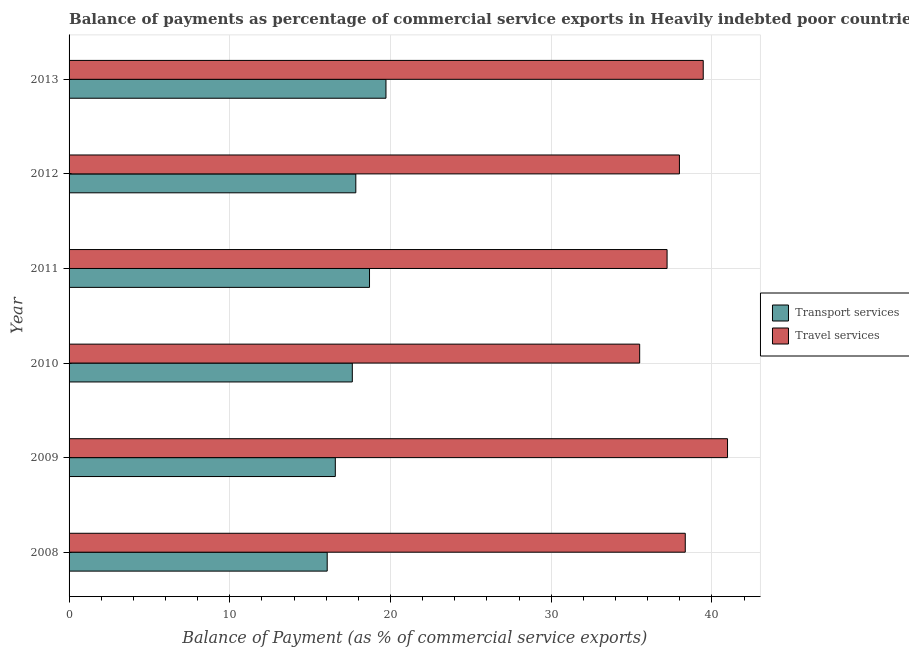How many groups of bars are there?
Ensure brevity in your answer.  6. Are the number of bars per tick equal to the number of legend labels?
Provide a short and direct response. Yes. How many bars are there on the 4th tick from the bottom?
Provide a succinct answer. 2. What is the label of the 5th group of bars from the top?
Provide a short and direct response. 2009. In how many cases, is the number of bars for a given year not equal to the number of legend labels?
Your answer should be very brief. 0. What is the balance of payments of transport services in 2013?
Provide a succinct answer. 19.72. Across all years, what is the maximum balance of payments of travel services?
Provide a succinct answer. 40.97. Across all years, what is the minimum balance of payments of transport services?
Your response must be concise. 16.06. In which year was the balance of payments of transport services maximum?
Provide a short and direct response. 2013. In which year was the balance of payments of transport services minimum?
Offer a terse response. 2008. What is the total balance of payments of transport services in the graph?
Make the answer very short. 106.5. What is the difference between the balance of payments of travel services in 2008 and that in 2013?
Give a very brief answer. -1.12. What is the difference between the balance of payments of travel services in 2013 and the balance of payments of transport services in 2010?
Provide a succinct answer. 21.83. What is the average balance of payments of travel services per year?
Ensure brevity in your answer.  38.24. In the year 2010, what is the difference between the balance of payments of transport services and balance of payments of travel services?
Your answer should be compact. -17.88. In how many years, is the balance of payments of travel services greater than 8 %?
Your answer should be compact. 6. What is the ratio of the balance of payments of transport services in 2009 to that in 2013?
Your response must be concise. 0.84. Is the balance of payments of transport services in 2009 less than that in 2010?
Give a very brief answer. Yes. Is the difference between the balance of payments of transport services in 2008 and 2009 greater than the difference between the balance of payments of travel services in 2008 and 2009?
Your answer should be very brief. Yes. What is the difference between the highest and the second highest balance of payments of transport services?
Provide a succinct answer. 1.02. What is the difference between the highest and the lowest balance of payments of travel services?
Make the answer very short. 5.47. What does the 1st bar from the top in 2010 represents?
Keep it short and to the point. Travel services. What does the 2nd bar from the bottom in 2009 represents?
Offer a terse response. Travel services. How many bars are there?
Your answer should be compact. 12. Are all the bars in the graph horizontal?
Provide a succinct answer. Yes. Are the values on the major ticks of X-axis written in scientific E-notation?
Offer a very short reply. No. What is the title of the graph?
Your answer should be very brief. Balance of payments as percentage of commercial service exports in Heavily indebted poor countries. Does "current US$" appear as one of the legend labels in the graph?
Your answer should be compact. No. What is the label or title of the X-axis?
Ensure brevity in your answer.  Balance of Payment (as % of commercial service exports). What is the Balance of Payment (as % of commercial service exports) in Transport services in 2008?
Offer a terse response. 16.06. What is the Balance of Payment (as % of commercial service exports) in Travel services in 2008?
Offer a terse response. 38.34. What is the Balance of Payment (as % of commercial service exports) of Transport services in 2009?
Keep it short and to the point. 16.57. What is the Balance of Payment (as % of commercial service exports) of Travel services in 2009?
Keep it short and to the point. 40.97. What is the Balance of Payment (as % of commercial service exports) in Transport services in 2010?
Your answer should be very brief. 17.62. What is the Balance of Payment (as % of commercial service exports) of Travel services in 2010?
Give a very brief answer. 35.5. What is the Balance of Payment (as % of commercial service exports) of Transport services in 2011?
Ensure brevity in your answer.  18.69. What is the Balance of Payment (as % of commercial service exports) in Travel services in 2011?
Offer a terse response. 37.21. What is the Balance of Payment (as % of commercial service exports) in Transport services in 2012?
Your answer should be compact. 17.84. What is the Balance of Payment (as % of commercial service exports) in Travel services in 2012?
Your answer should be very brief. 37.97. What is the Balance of Payment (as % of commercial service exports) in Transport services in 2013?
Provide a short and direct response. 19.72. What is the Balance of Payment (as % of commercial service exports) of Travel services in 2013?
Give a very brief answer. 39.46. Across all years, what is the maximum Balance of Payment (as % of commercial service exports) in Transport services?
Your answer should be compact. 19.72. Across all years, what is the maximum Balance of Payment (as % of commercial service exports) in Travel services?
Offer a very short reply. 40.97. Across all years, what is the minimum Balance of Payment (as % of commercial service exports) of Transport services?
Your answer should be very brief. 16.06. Across all years, what is the minimum Balance of Payment (as % of commercial service exports) in Travel services?
Your answer should be compact. 35.5. What is the total Balance of Payment (as % of commercial service exports) in Transport services in the graph?
Make the answer very short. 106.5. What is the total Balance of Payment (as % of commercial service exports) in Travel services in the graph?
Provide a succinct answer. 229.45. What is the difference between the Balance of Payment (as % of commercial service exports) in Transport services in 2008 and that in 2009?
Provide a short and direct response. -0.51. What is the difference between the Balance of Payment (as % of commercial service exports) in Travel services in 2008 and that in 2009?
Offer a very short reply. -2.63. What is the difference between the Balance of Payment (as % of commercial service exports) of Transport services in 2008 and that in 2010?
Your response must be concise. -1.56. What is the difference between the Balance of Payment (as % of commercial service exports) of Travel services in 2008 and that in 2010?
Provide a succinct answer. 2.84. What is the difference between the Balance of Payment (as % of commercial service exports) in Transport services in 2008 and that in 2011?
Your answer should be very brief. -2.63. What is the difference between the Balance of Payment (as % of commercial service exports) of Travel services in 2008 and that in 2011?
Offer a terse response. 1.13. What is the difference between the Balance of Payment (as % of commercial service exports) in Transport services in 2008 and that in 2012?
Make the answer very short. -1.78. What is the difference between the Balance of Payment (as % of commercial service exports) in Travel services in 2008 and that in 2012?
Your response must be concise. 0.36. What is the difference between the Balance of Payment (as % of commercial service exports) of Transport services in 2008 and that in 2013?
Offer a very short reply. -3.66. What is the difference between the Balance of Payment (as % of commercial service exports) in Travel services in 2008 and that in 2013?
Provide a succinct answer. -1.12. What is the difference between the Balance of Payment (as % of commercial service exports) of Transport services in 2009 and that in 2010?
Offer a terse response. -1.06. What is the difference between the Balance of Payment (as % of commercial service exports) of Travel services in 2009 and that in 2010?
Offer a very short reply. 5.47. What is the difference between the Balance of Payment (as % of commercial service exports) of Transport services in 2009 and that in 2011?
Offer a terse response. -2.13. What is the difference between the Balance of Payment (as % of commercial service exports) in Travel services in 2009 and that in 2011?
Provide a succinct answer. 3.76. What is the difference between the Balance of Payment (as % of commercial service exports) of Transport services in 2009 and that in 2012?
Provide a short and direct response. -1.27. What is the difference between the Balance of Payment (as % of commercial service exports) in Travel services in 2009 and that in 2012?
Provide a succinct answer. 2.99. What is the difference between the Balance of Payment (as % of commercial service exports) in Transport services in 2009 and that in 2013?
Ensure brevity in your answer.  -3.15. What is the difference between the Balance of Payment (as % of commercial service exports) of Travel services in 2009 and that in 2013?
Offer a terse response. 1.51. What is the difference between the Balance of Payment (as % of commercial service exports) of Transport services in 2010 and that in 2011?
Give a very brief answer. -1.07. What is the difference between the Balance of Payment (as % of commercial service exports) in Travel services in 2010 and that in 2011?
Your response must be concise. -1.71. What is the difference between the Balance of Payment (as % of commercial service exports) of Transport services in 2010 and that in 2012?
Keep it short and to the point. -0.22. What is the difference between the Balance of Payment (as % of commercial service exports) of Travel services in 2010 and that in 2012?
Your response must be concise. -2.47. What is the difference between the Balance of Payment (as % of commercial service exports) of Transport services in 2010 and that in 2013?
Offer a terse response. -2.09. What is the difference between the Balance of Payment (as % of commercial service exports) in Travel services in 2010 and that in 2013?
Provide a succinct answer. -3.95. What is the difference between the Balance of Payment (as % of commercial service exports) in Transport services in 2011 and that in 2012?
Make the answer very short. 0.85. What is the difference between the Balance of Payment (as % of commercial service exports) of Travel services in 2011 and that in 2012?
Your answer should be compact. -0.77. What is the difference between the Balance of Payment (as % of commercial service exports) of Transport services in 2011 and that in 2013?
Your answer should be very brief. -1.02. What is the difference between the Balance of Payment (as % of commercial service exports) in Travel services in 2011 and that in 2013?
Provide a short and direct response. -2.25. What is the difference between the Balance of Payment (as % of commercial service exports) of Transport services in 2012 and that in 2013?
Ensure brevity in your answer.  -1.88. What is the difference between the Balance of Payment (as % of commercial service exports) of Travel services in 2012 and that in 2013?
Your answer should be compact. -1.48. What is the difference between the Balance of Payment (as % of commercial service exports) of Transport services in 2008 and the Balance of Payment (as % of commercial service exports) of Travel services in 2009?
Make the answer very short. -24.91. What is the difference between the Balance of Payment (as % of commercial service exports) in Transport services in 2008 and the Balance of Payment (as % of commercial service exports) in Travel services in 2010?
Provide a short and direct response. -19.44. What is the difference between the Balance of Payment (as % of commercial service exports) of Transport services in 2008 and the Balance of Payment (as % of commercial service exports) of Travel services in 2011?
Ensure brevity in your answer.  -21.15. What is the difference between the Balance of Payment (as % of commercial service exports) in Transport services in 2008 and the Balance of Payment (as % of commercial service exports) in Travel services in 2012?
Offer a terse response. -21.91. What is the difference between the Balance of Payment (as % of commercial service exports) of Transport services in 2008 and the Balance of Payment (as % of commercial service exports) of Travel services in 2013?
Your response must be concise. -23.4. What is the difference between the Balance of Payment (as % of commercial service exports) of Transport services in 2009 and the Balance of Payment (as % of commercial service exports) of Travel services in 2010?
Offer a terse response. -18.94. What is the difference between the Balance of Payment (as % of commercial service exports) of Transport services in 2009 and the Balance of Payment (as % of commercial service exports) of Travel services in 2011?
Make the answer very short. -20.64. What is the difference between the Balance of Payment (as % of commercial service exports) of Transport services in 2009 and the Balance of Payment (as % of commercial service exports) of Travel services in 2012?
Your answer should be very brief. -21.41. What is the difference between the Balance of Payment (as % of commercial service exports) of Transport services in 2009 and the Balance of Payment (as % of commercial service exports) of Travel services in 2013?
Offer a terse response. -22.89. What is the difference between the Balance of Payment (as % of commercial service exports) of Transport services in 2010 and the Balance of Payment (as % of commercial service exports) of Travel services in 2011?
Give a very brief answer. -19.58. What is the difference between the Balance of Payment (as % of commercial service exports) in Transport services in 2010 and the Balance of Payment (as % of commercial service exports) in Travel services in 2012?
Your answer should be very brief. -20.35. What is the difference between the Balance of Payment (as % of commercial service exports) of Transport services in 2010 and the Balance of Payment (as % of commercial service exports) of Travel services in 2013?
Provide a succinct answer. -21.83. What is the difference between the Balance of Payment (as % of commercial service exports) in Transport services in 2011 and the Balance of Payment (as % of commercial service exports) in Travel services in 2012?
Your response must be concise. -19.28. What is the difference between the Balance of Payment (as % of commercial service exports) of Transport services in 2011 and the Balance of Payment (as % of commercial service exports) of Travel services in 2013?
Keep it short and to the point. -20.76. What is the difference between the Balance of Payment (as % of commercial service exports) in Transport services in 2012 and the Balance of Payment (as % of commercial service exports) in Travel services in 2013?
Give a very brief answer. -21.62. What is the average Balance of Payment (as % of commercial service exports) in Transport services per year?
Offer a terse response. 17.75. What is the average Balance of Payment (as % of commercial service exports) in Travel services per year?
Offer a very short reply. 38.24. In the year 2008, what is the difference between the Balance of Payment (as % of commercial service exports) of Transport services and Balance of Payment (as % of commercial service exports) of Travel services?
Provide a short and direct response. -22.28. In the year 2009, what is the difference between the Balance of Payment (as % of commercial service exports) of Transport services and Balance of Payment (as % of commercial service exports) of Travel services?
Your answer should be very brief. -24.4. In the year 2010, what is the difference between the Balance of Payment (as % of commercial service exports) in Transport services and Balance of Payment (as % of commercial service exports) in Travel services?
Make the answer very short. -17.88. In the year 2011, what is the difference between the Balance of Payment (as % of commercial service exports) in Transport services and Balance of Payment (as % of commercial service exports) in Travel services?
Your answer should be very brief. -18.51. In the year 2012, what is the difference between the Balance of Payment (as % of commercial service exports) in Transport services and Balance of Payment (as % of commercial service exports) in Travel services?
Offer a very short reply. -20.13. In the year 2013, what is the difference between the Balance of Payment (as % of commercial service exports) in Transport services and Balance of Payment (as % of commercial service exports) in Travel services?
Provide a short and direct response. -19.74. What is the ratio of the Balance of Payment (as % of commercial service exports) in Transport services in 2008 to that in 2009?
Offer a terse response. 0.97. What is the ratio of the Balance of Payment (as % of commercial service exports) of Travel services in 2008 to that in 2009?
Make the answer very short. 0.94. What is the ratio of the Balance of Payment (as % of commercial service exports) in Transport services in 2008 to that in 2010?
Your response must be concise. 0.91. What is the ratio of the Balance of Payment (as % of commercial service exports) in Travel services in 2008 to that in 2010?
Provide a short and direct response. 1.08. What is the ratio of the Balance of Payment (as % of commercial service exports) of Transport services in 2008 to that in 2011?
Your answer should be very brief. 0.86. What is the ratio of the Balance of Payment (as % of commercial service exports) of Travel services in 2008 to that in 2011?
Give a very brief answer. 1.03. What is the ratio of the Balance of Payment (as % of commercial service exports) in Transport services in 2008 to that in 2012?
Provide a succinct answer. 0.9. What is the ratio of the Balance of Payment (as % of commercial service exports) in Travel services in 2008 to that in 2012?
Make the answer very short. 1.01. What is the ratio of the Balance of Payment (as % of commercial service exports) of Transport services in 2008 to that in 2013?
Your answer should be very brief. 0.81. What is the ratio of the Balance of Payment (as % of commercial service exports) in Travel services in 2008 to that in 2013?
Provide a succinct answer. 0.97. What is the ratio of the Balance of Payment (as % of commercial service exports) of Transport services in 2009 to that in 2010?
Provide a succinct answer. 0.94. What is the ratio of the Balance of Payment (as % of commercial service exports) of Travel services in 2009 to that in 2010?
Provide a succinct answer. 1.15. What is the ratio of the Balance of Payment (as % of commercial service exports) in Transport services in 2009 to that in 2011?
Offer a terse response. 0.89. What is the ratio of the Balance of Payment (as % of commercial service exports) in Travel services in 2009 to that in 2011?
Offer a very short reply. 1.1. What is the ratio of the Balance of Payment (as % of commercial service exports) in Transport services in 2009 to that in 2012?
Offer a very short reply. 0.93. What is the ratio of the Balance of Payment (as % of commercial service exports) of Travel services in 2009 to that in 2012?
Provide a succinct answer. 1.08. What is the ratio of the Balance of Payment (as % of commercial service exports) in Transport services in 2009 to that in 2013?
Provide a short and direct response. 0.84. What is the ratio of the Balance of Payment (as % of commercial service exports) of Travel services in 2009 to that in 2013?
Offer a terse response. 1.04. What is the ratio of the Balance of Payment (as % of commercial service exports) in Transport services in 2010 to that in 2011?
Your response must be concise. 0.94. What is the ratio of the Balance of Payment (as % of commercial service exports) in Travel services in 2010 to that in 2011?
Ensure brevity in your answer.  0.95. What is the ratio of the Balance of Payment (as % of commercial service exports) in Travel services in 2010 to that in 2012?
Your response must be concise. 0.93. What is the ratio of the Balance of Payment (as % of commercial service exports) of Transport services in 2010 to that in 2013?
Make the answer very short. 0.89. What is the ratio of the Balance of Payment (as % of commercial service exports) of Travel services in 2010 to that in 2013?
Offer a terse response. 0.9. What is the ratio of the Balance of Payment (as % of commercial service exports) of Transport services in 2011 to that in 2012?
Provide a succinct answer. 1.05. What is the ratio of the Balance of Payment (as % of commercial service exports) of Travel services in 2011 to that in 2012?
Your response must be concise. 0.98. What is the ratio of the Balance of Payment (as % of commercial service exports) in Transport services in 2011 to that in 2013?
Offer a very short reply. 0.95. What is the ratio of the Balance of Payment (as % of commercial service exports) in Travel services in 2011 to that in 2013?
Make the answer very short. 0.94. What is the ratio of the Balance of Payment (as % of commercial service exports) in Transport services in 2012 to that in 2013?
Ensure brevity in your answer.  0.9. What is the ratio of the Balance of Payment (as % of commercial service exports) in Travel services in 2012 to that in 2013?
Provide a succinct answer. 0.96. What is the difference between the highest and the second highest Balance of Payment (as % of commercial service exports) in Transport services?
Provide a short and direct response. 1.02. What is the difference between the highest and the second highest Balance of Payment (as % of commercial service exports) in Travel services?
Ensure brevity in your answer.  1.51. What is the difference between the highest and the lowest Balance of Payment (as % of commercial service exports) in Transport services?
Provide a short and direct response. 3.66. What is the difference between the highest and the lowest Balance of Payment (as % of commercial service exports) of Travel services?
Your answer should be very brief. 5.47. 